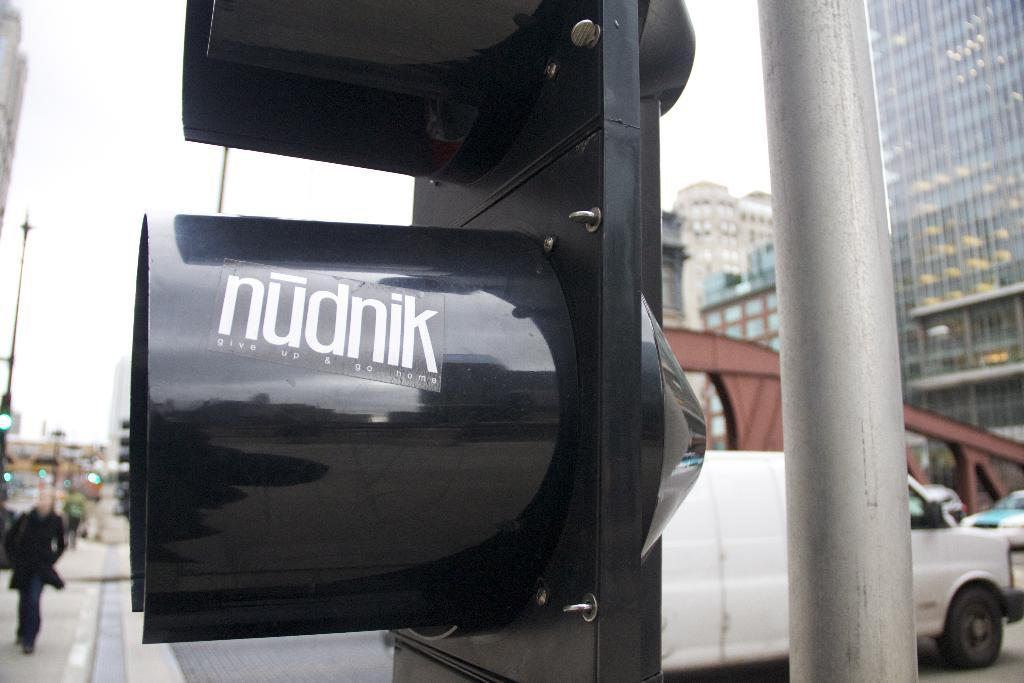<image>
Provide a brief description of the given image. A traffic light has a sticker on it that says nudnik. 